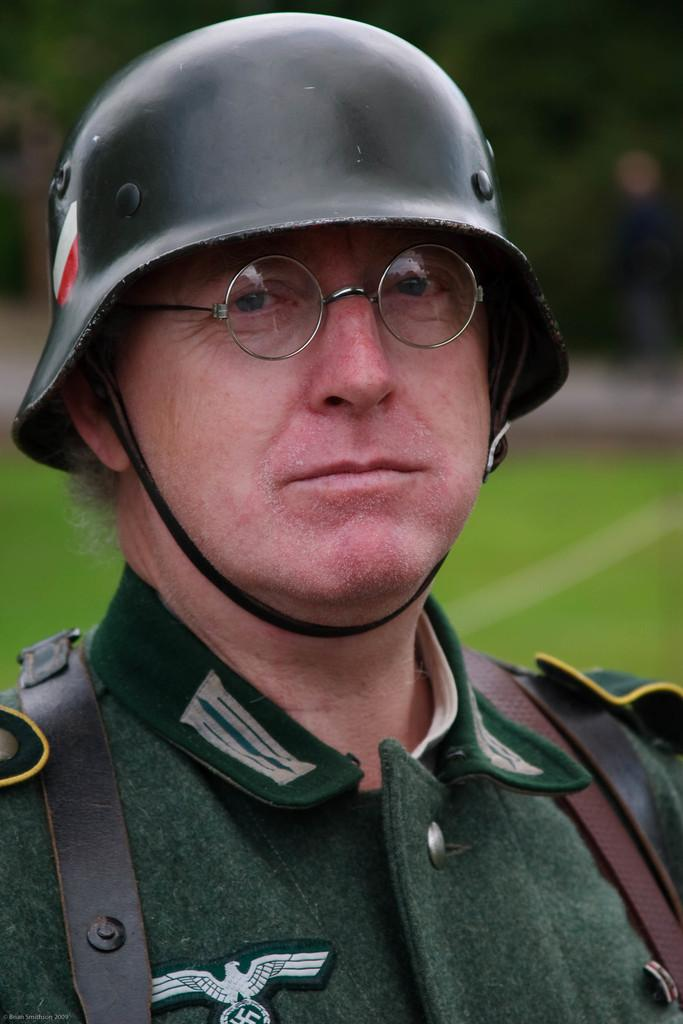Who or what is present in the image? There is a person in the image. What is the person wearing on their head? The person is wearing a helmet. What type of terrain is visible in the image? There is grassy land in the image. What other natural elements can be seen in the image? There are trees in the image. What type of fruit is hanging from the trees in the image? There is no fruit visible in the image; only trees are present. 